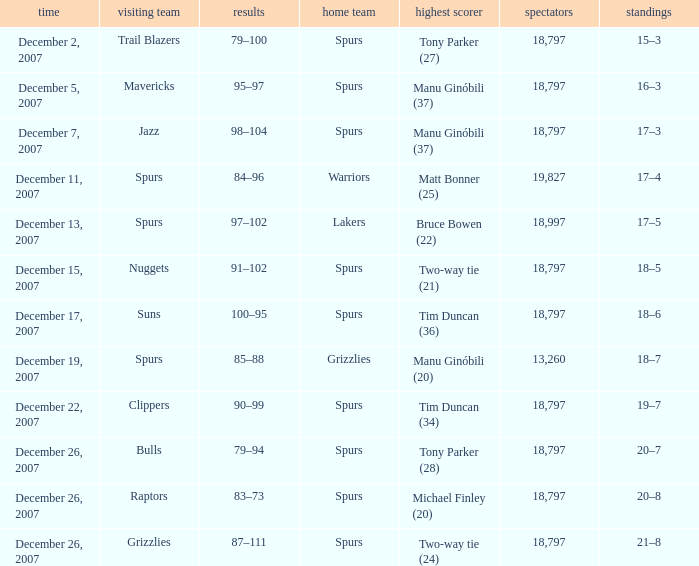What is the record of the game on December 5, 2007? 16–3. 